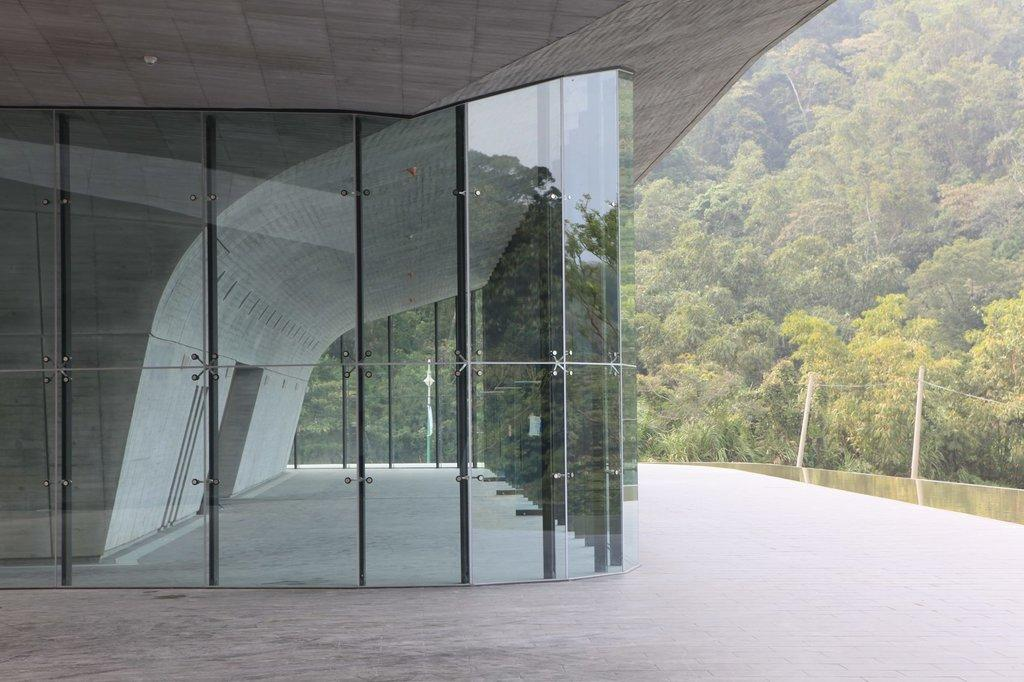What type of building is visible in the image? There is a building with a glass wall in the image. What can be seen in the background of the image? There is a boundary and trees present in the background of the image. How do the lizards react to the presence of the rat in the image? There are no lizards or rat present in the image. 